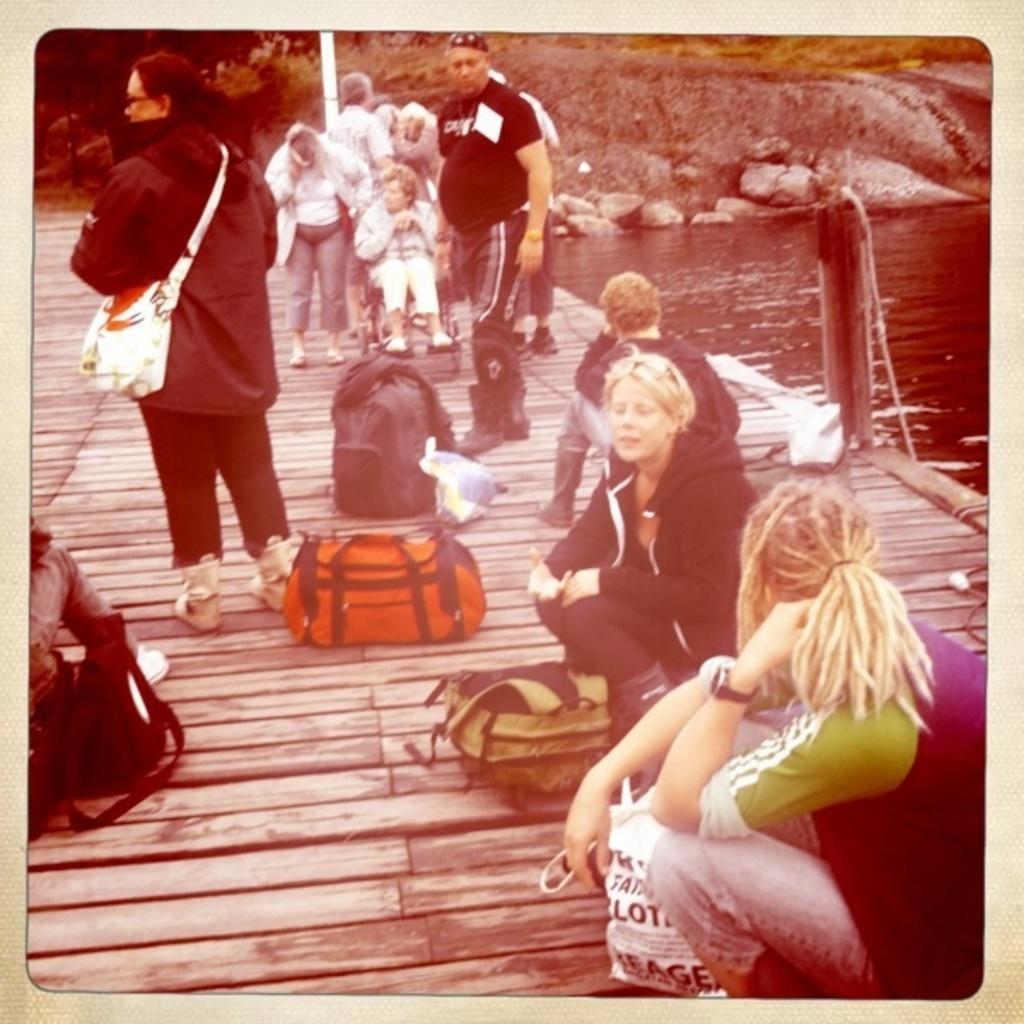Please provide a concise description of this image. This is an edited image. On the left side, I can see a wooden plank on which few people are standing, few people are sitting. Along with the people there are few bags. On the right side, I can see the water. In the background there is a rock. 